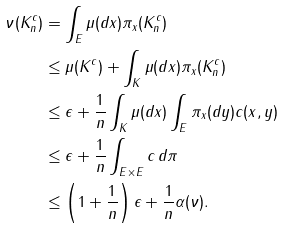Convert formula to latex. <formula><loc_0><loc_0><loc_500><loc_500>\nu ( K _ { n } ^ { c } ) & = \int _ { E } \mu ( d x ) \pi _ { x } ( K _ { n } ^ { c } ) \\ & \leq \mu ( K ^ { c } ) + \int _ { K } \mu ( d x ) \pi _ { x } ( K _ { n } ^ { c } ) \\ & \leq \epsilon + \frac { 1 } { n } \int _ { K } \mu ( d x ) \int _ { E } \pi _ { x } ( d y ) c ( x , y ) \\ & \leq \epsilon + \frac { 1 } { n } \int _ { E \times E } c \, d \pi \\ & \leq \left ( 1 + \frac { 1 } { n } \right ) \epsilon + \frac { 1 } { n } \alpha ( \nu ) .</formula> 